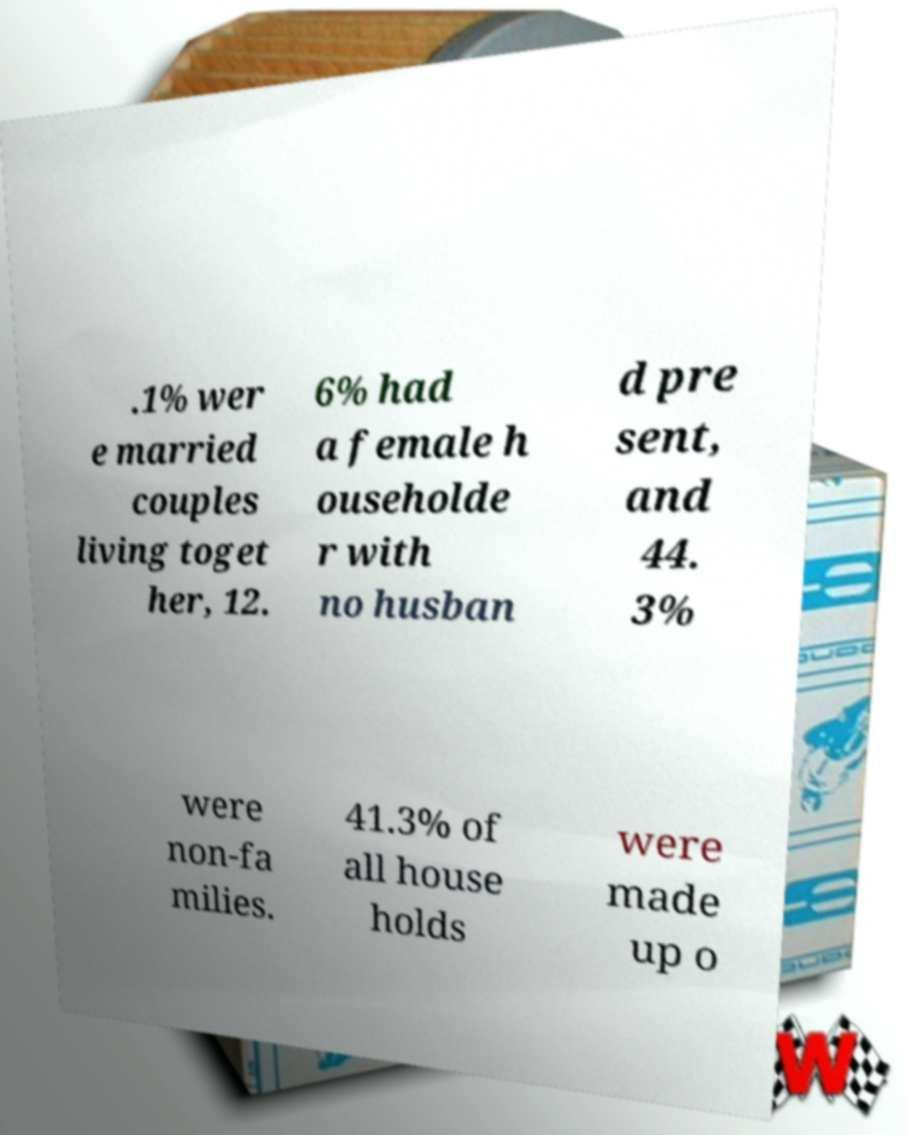I need the written content from this picture converted into text. Can you do that? .1% wer e married couples living toget her, 12. 6% had a female h ouseholde r with no husban d pre sent, and 44. 3% were non-fa milies. 41.3% of all house holds were made up o 